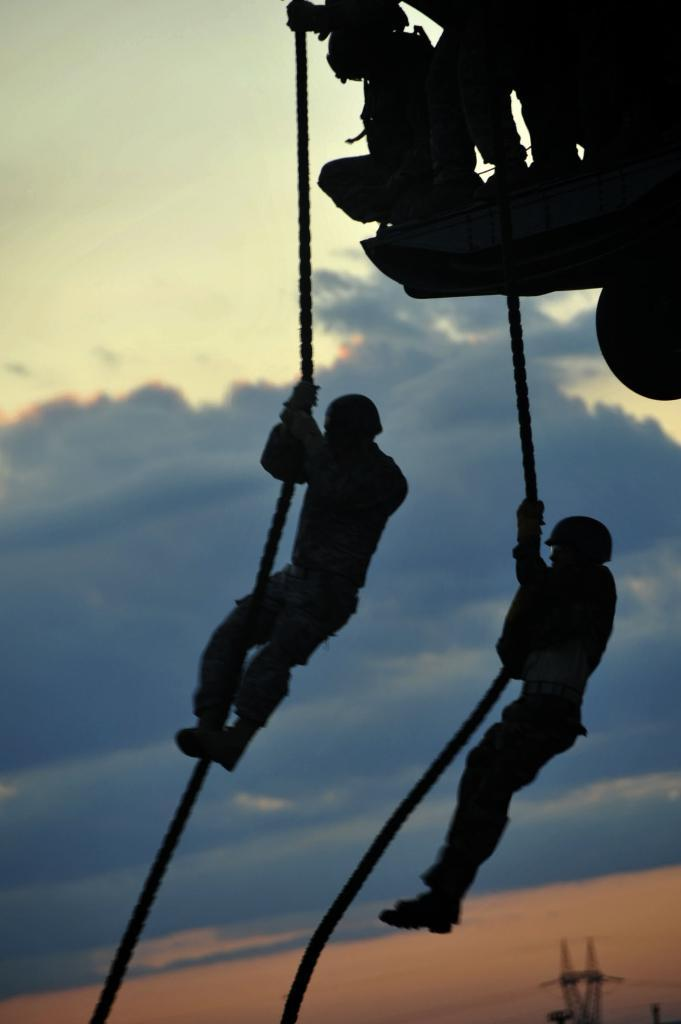What are the two persons in the image doing? The two persons in the image are climbing on a rope. Are there any other people involved in the activity? Yes, there are other persons at the top of the rope. What can be seen in the background of the image? There are trees and hills in the background of the image. How is the weather in the image? The sky is clear in the image. What type of doll is sitting on the coach's knee in the image? There is no doll or coach present in the image. 